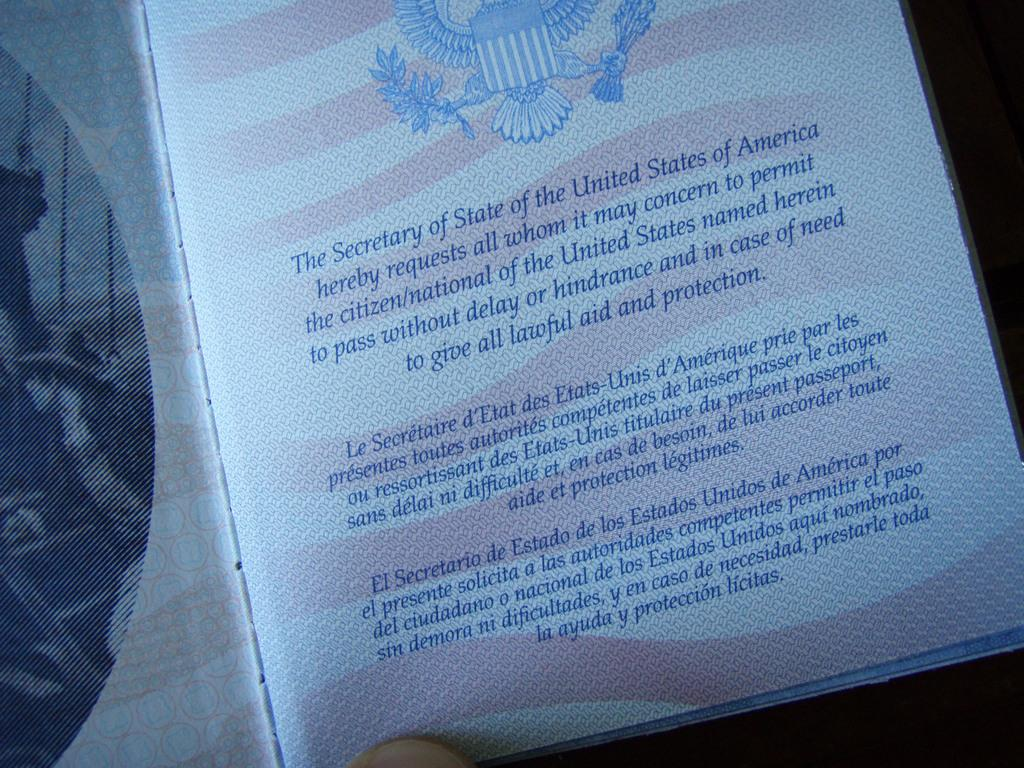<image>
Present a compact description of the photo's key features. The inside portion of a United States passport. 